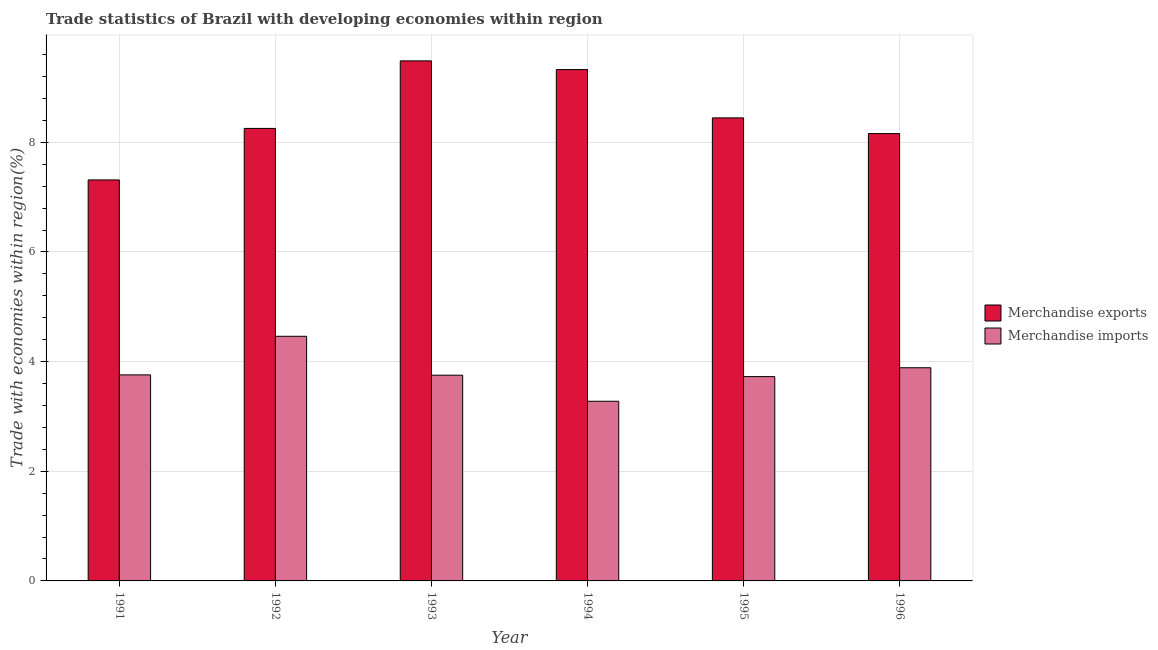How many different coloured bars are there?
Offer a terse response. 2. How many groups of bars are there?
Your answer should be very brief. 6. Are the number of bars per tick equal to the number of legend labels?
Provide a succinct answer. Yes. Are the number of bars on each tick of the X-axis equal?
Your answer should be compact. Yes. How many bars are there on the 6th tick from the left?
Ensure brevity in your answer.  2. What is the label of the 6th group of bars from the left?
Offer a very short reply. 1996. What is the merchandise exports in 1994?
Your answer should be compact. 9.33. Across all years, what is the maximum merchandise exports?
Ensure brevity in your answer.  9.49. Across all years, what is the minimum merchandise exports?
Your answer should be very brief. 7.31. What is the total merchandise imports in the graph?
Keep it short and to the point. 22.86. What is the difference between the merchandise imports in 1992 and that in 1994?
Your response must be concise. 1.18. What is the difference between the merchandise imports in 1996 and the merchandise exports in 1995?
Keep it short and to the point. 0.16. What is the average merchandise imports per year?
Keep it short and to the point. 3.81. What is the ratio of the merchandise imports in 1993 to that in 1996?
Offer a very short reply. 0.97. Is the difference between the merchandise imports in 1995 and 1996 greater than the difference between the merchandise exports in 1995 and 1996?
Ensure brevity in your answer.  No. What is the difference between the highest and the second highest merchandise exports?
Give a very brief answer. 0.16. What is the difference between the highest and the lowest merchandise imports?
Your response must be concise. 1.18. Is the sum of the merchandise imports in 1992 and 1993 greater than the maximum merchandise exports across all years?
Your answer should be compact. Yes. What does the 2nd bar from the left in 1991 represents?
Give a very brief answer. Merchandise imports. Are all the bars in the graph horizontal?
Your answer should be compact. No. Are the values on the major ticks of Y-axis written in scientific E-notation?
Your answer should be compact. No. Where does the legend appear in the graph?
Ensure brevity in your answer.  Center right. How many legend labels are there?
Offer a terse response. 2. What is the title of the graph?
Your answer should be very brief. Trade statistics of Brazil with developing economies within region. What is the label or title of the X-axis?
Provide a succinct answer. Year. What is the label or title of the Y-axis?
Provide a succinct answer. Trade with economies within region(%). What is the Trade with economies within region(%) in Merchandise exports in 1991?
Your answer should be very brief. 7.31. What is the Trade with economies within region(%) of Merchandise imports in 1991?
Provide a short and direct response. 3.76. What is the Trade with economies within region(%) of Merchandise exports in 1992?
Your response must be concise. 8.25. What is the Trade with economies within region(%) of Merchandise imports in 1992?
Your response must be concise. 4.46. What is the Trade with economies within region(%) of Merchandise exports in 1993?
Your answer should be compact. 9.49. What is the Trade with economies within region(%) of Merchandise imports in 1993?
Your answer should be compact. 3.75. What is the Trade with economies within region(%) in Merchandise exports in 1994?
Your answer should be very brief. 9.33. What is the Trade with economies within region(%) in Merchandise imports in 1994?
Provide a succinct answer. 3.28. What is the Trade with economies within region(%) of Merchandise exports in 1995?
Ensure brevity in your answer.  8.45. What is the Trade with economies within region(%) of Merchandise imports in 1995?
Your answer should be compact. 3.73. What is the Trade with economies within region(%) in Merchandise exports in 1996?
Provide a short and direct response. 8.16. What is the Trade with economies within region(%) of Merchandise imports in 1996?
Ensure brevity in your answer.  3.89. Across all years, what is the maximum Trade with economies within region(%) in Merchandise exports?
Provide a succinct answer. 9.49. Across all years, what is the maximum Trade with economies within region(%) in Merchandise imports?
Give a very brief answer. 4.46. Across all years, what is the minimum Trade with economies within region(%) in Merchandise exports?
Make the answer very short. 7.31. Across all years, what is the minimum Trade with economies within region(%) of Merchandise imports?
Ensure brevity in your answer.  3.28. What is the total Trade with economies within region(%) of Merchandise exports in the graph?
Ensure brevity in your answer.  50.99. What is the total Trade with economies within region(%) in Merchandise imports in the graph?
Provide a short and direct response. 22.86. What is the difference between the Trade with economies within region(%) in Merchandise exports in 1991 and that in 1992?
Ensure brevity in your answer.  -0.94. What is the difference between the Trade with economies within region(%) of Merchandise imports in 1991 and that in 1992?
Ensure brevity in your answer.  -0.7. What is the difference between the Trade with economies within region(%) of Merchandise exports in 1991 and that in 1993?
Provide a succinct answer. -2.17. What is the difference between the Trade with economies within region(%) of Merchandise imports in 1991 and that in 1993?
Your answer should be compact. 0.01. What is the difference between the Trade with economies within region(%) in Merchandise exports in 1991 and that in 1994?
Provide a short and direct response. -2.01. What is the difference between the Trade with economies within region(%) of Merchandise imports in 1991 and that in 1994?
Provide a succinct answer. 0.48. What is the difference between the Trade with economies within region(%) of Merchandise exports in 1991 and that in 1995?
Offer a terse response. -1.13. What is the difference between the Trade with economies within region(%) in Merchandise imports in 1991 and that in 1995?
Make the answer very short. 0.03. What is the difference between the Trade with economies within region(%) in Merchandise exports in 1991 and that in 1996?
Your response must be concise. -0.85. What is the difference between the Trade with economies within region(%) in Merchandise imports in 1991 and that in 1996?
Your answer should be compact. -0.13. What is the difference between the Trade with economies within region(%) of Merchandise exports in 1992 and that in 1993?
Give a very brief answer. -1.23. What is the difference between the Trade with economies within region(%) of Merchandise imports in 1992 and that in 1993?
Provide a short and direct response. 0.71. What is the difference between the Trade with economies within region(%) of Merchandise exports in 1992 and that in 1994?
Offer a very short reply. -1.07. What is the difference between the Trade with economies within region(%) of Merchandise imports in 1992 and that in 1994?
Offer a terse response. 1.18. What is the difference between the Trade with economies within region(%) of Merchandise exports in 1992 and that in 1995?
Keep it short and to the point. -0.19. What is the difference between the Trade with economies within region(%) in Merchandise imports in 1992 and that in 1995?
Provide a short and direct response. 0.74. What is the difference between the Trade with economies within region(%) of Merchandise exports in 1992 and that in 1996?
Your answer should be very brief. 0.09. What is the difference between the Trade with economies within region(%) of Merchandise imports in 1992 and that in 1996?
Provide a succinct answer. 0.57. What is the difference between the Trade with economies within region(%) in Merchandise exports in 1993 and that in 1994?
Ensure brevity in your answer.  0.16. What is the difference between the Trade with economies within region(%) of Merchandise imports in 1993 and that in 1994?
Your answer should be very brief. 0.48. What is the difference between the Trade with economies within region(%) in Merchandise exports in 1993 and that in 1995?
Make the answer very short. 1.04. What is the difference between the Trade with economies within region(%) in Merchandise imports in 1993 and that in 1995?
Ensure brevity in your answer.  0.03. What is the difference between the Trade with economies within region(%) in Merchandise exports in 1993 and that in 1996?
Provide a short and direct response. 1.33. What is the difference between the Trade with economies within region(%) in Merchandise imports in 1993 and that in 1996?
Make the answer very short. -0.14. What is the difference between the Trade with economies within region(%) in Merchandise exports in 1994 and that in 1995?
Ensure brevity in your answer.  0.88. What is the difference between the Trade with economies within region(%) in Merchandise imports in 1994 and that in 1995?
Offer a very short reply. -0.45. What is the difference between the Trade with economies within region(%) of Merchandise exports in 1994 and that in 1996?
Your answer should be compact. 1.17. What is the difference between the Trade with economies within region(%) of Merchandise imports in 1994 and that in 1996?
Your response must be concise. -0.61. What is the difference between the Trade with economies within region(%) of Merchandise exports in 1995 and that in 1996?
Provide a succinct answer. 0.29. What is the difference between the Trade with economies within region(%) in Merchandise imports in 1995 and that in 1996?
Offer a very short reply. -0.16. What is the difference between the Trade with economies within region(%) of Merchandise exports in 1991 and the Trade with economies within region(%) of Merchandise imports in 1992?
Offer a terse response. 2.85. What is the difference between the Trade with economies within region(%) of Merchandise exports in 1991 and the Trade with economies within region(%) of Merchandise imports in 1993?
Your answer should be very brief. 3.56. What is the difference between the Trade with economies within region(%) of Merchandise exports in 1991 and the Trade with economies within region(%) of Merchandise imports in 1994?
Give a very brief answer. 4.04. What is the difference between the Trade with economies within region(%) in Merchandise exports in 1991 and the Trade with economies within region(%) in Merchandise imports in 1995?
Make the answer very short. 3.59. What is the difference between the Trade with economies within region(%) in Merchandise exports in 1991 and the Trade with economies within region(%) in Merchandise imports in 1996?
Make the answer very short. 3.43. What is the difference between the Trade with economies within region(%) of Merchandise exports in 1992 and the Trade with economies within region(%) of Merchandise imports in 1993?
Your answer should be very brief. 4.5. What is the difference between the Trade with economies within region(%) of Merchandise exports in 1992 and the Trade with economies within region(%) of Merchandise imports in 1994?
Offer a terse response. 4.98. What is the difference between the Trade with economies within region(%) of Merchandise exports in 1992 and the Trade with economies within region(%) of Merchandise imports in 1995?
Keep it short and to the point. 4.53. What is the difference between the Trade with economies within region(%) in Merchandise exports in 1992 and the Trade with economies within region(%) in Merchandise imports in 1996?
Offer a very short reply. 4.37. What is the difference between the Trade with economies within region(%) of Merchandise exports in 1993 and the Trade with economies within region(%) of Merchandise imports in 1994?
Your response must be concise. 6.21. What is the difference between the Trade with economies within region(%) of Merchandise exports in 1993 and the Trade with economies within region(%) of Merchandise imports in 1995?
Your answer should be very brief. 5.76. What is the difference between the Trade with economies within region(%) of Merchandise exports in 1993 and the Trade with economies within region(%) of Merchandise imports in 1996?
Offer a very short reply. 5.6. What is the difference between the Trade with economies within region(%) in Merchandise exports in 1994 and the Trade with economies within region(%) in Merchandise imports in 1995?
Offer a very short reply. 5.6. What is the difference between the Trade with economies within region(%) of Merchandise exports in 1994 and the Trade with economies within region(%) of Merchandise imports in 1996?
Give a very brief answer. 5.44. What is the difference between the Trade with economies within region(%) of Merchandise exports in 1995 and the Trade with economies within region(%) of Merchandise imports in 1996?
Your answer should be very brief. 4.56. What is the average Trade with economies within region(%) in Merchandise exports per year?
Give a very brief answer. 8.5. What is the average Trade with economies within region(%) of Merchandise imports per year?
Provide a succinct answer. 3.81. In the year 1991, what is the difference between the Trade with economies within region(%) in Merchandise exports and Trade with economies within region(%) in Merchandise imports?
Your answer should be compact. 3.56. In the year 1992, what is the difference between the Trade with economies within region(%) in Merchandise exports and Trade with economies within region(%) in Merchandise imports?
Make the answer very short. 3.79. In the year 1993, what is the difference between the Trade with economies within region(%) of Merchandise exports and Trade with economies within region(%) of Merchandise imports?
Offer a very short reply. 5.73. In the year 1994, what is the difference between the Trade with economies within region(%) of Merchandise exports and Trade with economies within region(%) of Merchandise imports?
Your answer should be compact. 6.05. In the year 1995, what is the difference between the Trade with economies within region(%) in Merchandise exports and Trade with economies within region(%) in Merchandise imports?
Your response must be concise. 4.72. In the year 1996, what is the difference between the Trade with economies within region(%) of Merchandise exports and Trade with economies within region(%) of Merchandise imports?
Offer a terse response. 4.27. What is the ratio of the Trade with economies within region(%) of Merchandise exports in 1991 to that in 1992?
Provide a short and direct response. 0.89. What is the ratio of the Trade with economies within region(%) in Merchandise imports in 1991 to that in 1992?
Offer a very short reply. 0.84. What is the ratio of the Trade with economies within region(%) in Merchandise exports in 1991 to that in 1993?
Offer a very short reply. 0.77. What is the ratio of the Trade with economies within region(%) in Merchandise imports in 1991 to that in 1993?
Offer a terse response. 1. What is the ratio of the Trade with economies within region(%) in Merchandise exports in 1991 to that in 1994?
Your answer should be compact. 0.78. What is the ratio of the Trade with economies within region(%) of Merchandise imports in 1991 to that in 1994?
Give a very brief answer. 1.15. What is the ratio of the Trade with economies within region(%) of Merchandise exports in 1991 to that in 1995?
Provide a succinct answer. 0.87. What is the ratio of the Trade with economies within region(%) in Merchandise imports in 1991 to that in 1995?
Keep it short and to the point. 1.01. What is the ratio of the Trade with economies within region(%) of Merchandise exports in 1991 to that in 1996?
Keep it short and to the point. 0.9. What is the ratio of the Trade with economies within region(%) in Merchandise imports in 1991 to that in 1996?
Provide a succinct answer. 0.97. What is the ratio of the Trade with economies within region(%) of Merchandise exports in 1992 to that in 1993?
Your answer should be compact. 0.87. What is the ratio of the Trade with economies within region(%) in Merchandise imports in 1992 to that in 1993?
Your answer should be compact. 1.19. What is the ratio of the Trade with economies within region(%) of Merchandise exports in 1992 to that in 1994?
Ensure brevity in your answer.  0.88. What is the ratio of the Trade with economies within region(%) of Merchandise imports in 1992 to that in 1994?
Offer a terse response. 1.36. What is the ratio of the Trade with economies within region(%) of Merchandise exports in 1992 to that in 1995?
Make the answer very short. 0.98. What is the ratio of the Trade with economies within region(%) in Merchandise imports in 1992 to that in 1995?
Your answer should be compact. 1.2. What is the ratio of the Trade with economies within region(%) of Merchandise exports in 1992 to that in 1996?
Keep it short and to the point. 1.01. What is the ratio of the Trade with economies within region(%) in Merchandise imports in 1992 to that in 1996?
Provide a short and direct response. 1.15. What is the ratio of the Trade with economies within region(%) of Merchandise imports in 1993 to that in 1994?
Your response must be concise. 1.15. What is the ratio of the Trade with economies within region(%) in Merchandise exports in 1993 to that in 1995?
Your answer should be compact. 1.12. What is the ratio of the Trade with economies within region(%) in Merchandise exports in 1993 to that in 1996?
Offer a very short reply. 1.16. What is the ratio of the Trade with economies within region(%) of Merchandise imports in 1993 to that in 1996?
Provide a short and direct response. 0.97. What is the ratio of the Trade with economies within region(%) in Merchandise exports in 1994 to that in 1995?
Keep it short and to the point. 1.1. What is the ratio of the Trade with economies within region(%) of Merchandise imports in 1994 to that in 1995?
Make the answer very short. 0.88. What is the ratio of the Trade with economies within region(%) in Merchandise exports in 1994 to that in 1996?
Your answer should be very brief. 1.14. What is the ratio of the Trade with economies within region(%) of Merchandise imports in 1994 to that in 1996?
Offer a very short reply. 0.84. What is the ratio of the Trade with economies within region(%) of Merchandise exports in 1995 to that in 1996?
Your answer should be compact. 1.04. What is the ratio of the Trade with economies within region(%) of Merchandise imports in 1995 to that in 1996?
Provide a succinct answer. 0.96. What is the difference between the highest and the second highest Trade with economies within region(%) in Merchandise exports?
Your response must be concise. 0.16. What is the difference between the highest and the second highest Trade with economies within region(%) of Merchandise imports?
Ensure brevity in your answer.  0.57. What is the difference between the highest and the lowest Trade with economies within region(%) of Merchandise exports?
Offer a very short reply. 2.17. What is the difference between the highest and the lowest Trade with economies within region(%) of Merchandise imports?
Keep it short and to the point. 1.18. 